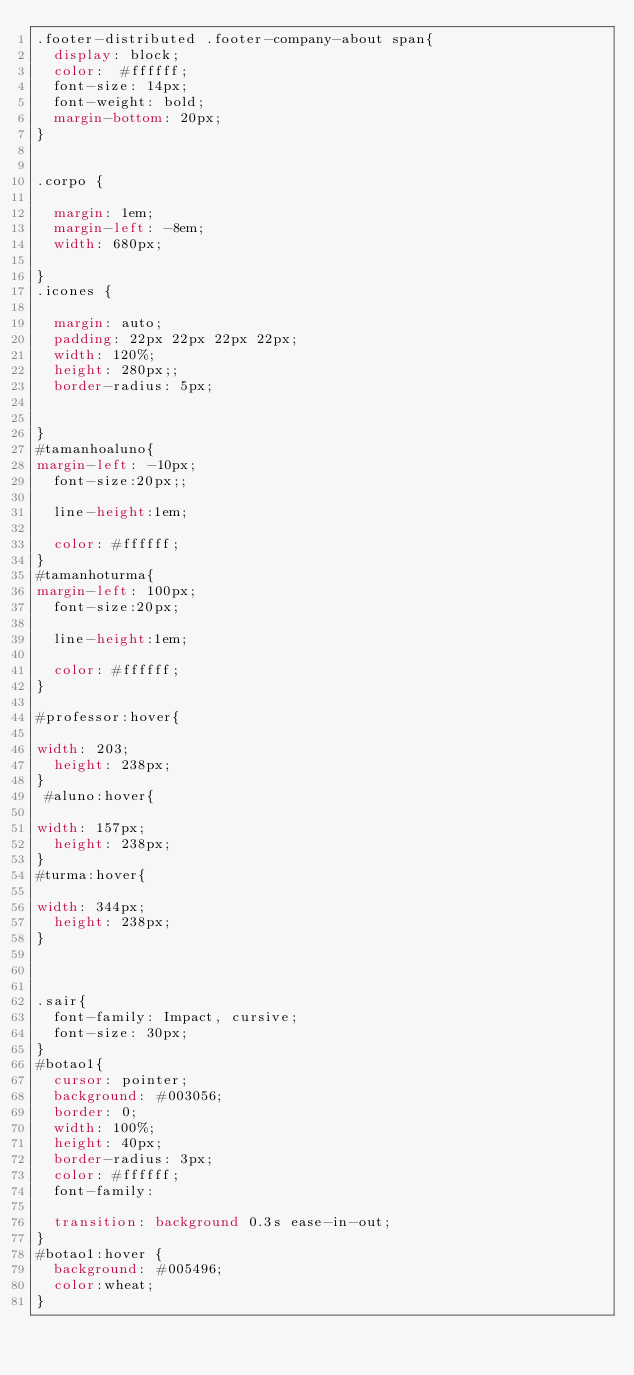<code> <loc_0><loc_0><loc_500><loc_500><_CSS_>.footer-distributed .footer-company-about span{
	display: block;
	color:  #ffffff;
	font-size: 14px;
	font-weight: bold;
	margin-bottom: 20px;
}


.corpo {
 	
  margin: 1em;
	margin-left: -8em;
  width: 680px;
	
}
.icones {
	
  margin: auto;
  padding: 22px 22px 22px 22px;
  width: 120%;
	height: 280px;;
  border-radius: 5px;
 
  
}
#tamanhoaluno{
margin-left: -10px;
  font-size:20px;; 

  line-height:1em;
  
  color: #ffffff;
}
#tamanhoturma{
margin-left: 100px;
  font-size:20px; 

  line-height:1em;
  
  color: #ffffff;
}

#professor:hover{
	
width: 203;
	height: 238px;
}
 #aluno:hover{
	
width: 157px;
	height: 238px;
}
#turma:hover{
	
width: 344px;
	height: 238px;
}



.sair{
	font-family: Impact, cursive;
	font-size: 30px;
}
#botao1{
	cursor: pointer;
  background: #003056;
  border: 0;
  width: 100%;
  height: 40px;
  border-radius: 3px;
  color: #ffffff;
	font-family: 
  
  transition: background 0.3s ease-in-out;
}
#botao1:hover {
  background: #005496;
	color:wheat;
}</code> 